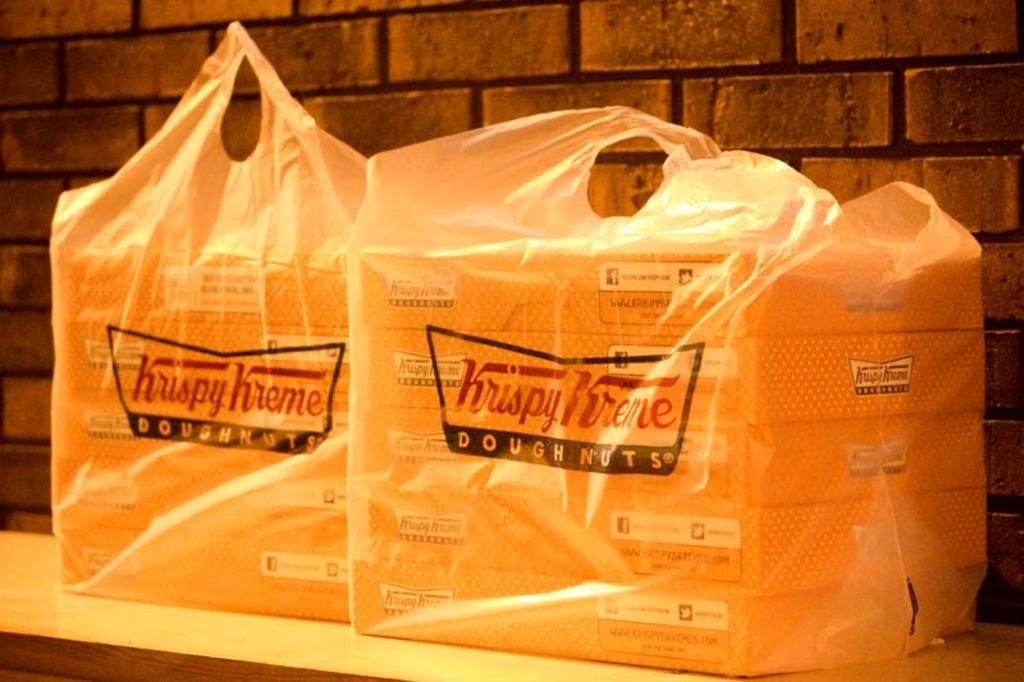How many covers are visible in the image? There are two covers visible in the image. What type of structure is present in the background? There is a brick wall in the background. What type of birthday celebration is taking place in the image? There is no indication of a birthday celebration in the image. How many daughters can be seen in the image? There are no people, let alone daughters, present in the image. 